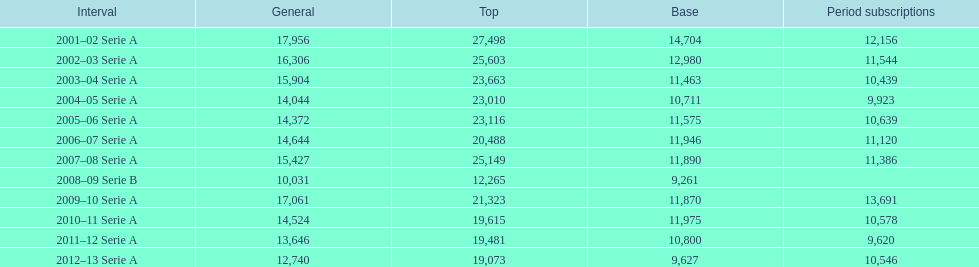How many seasons at the stadio ennio tardini had 11,000 or more season tickets? 5. 